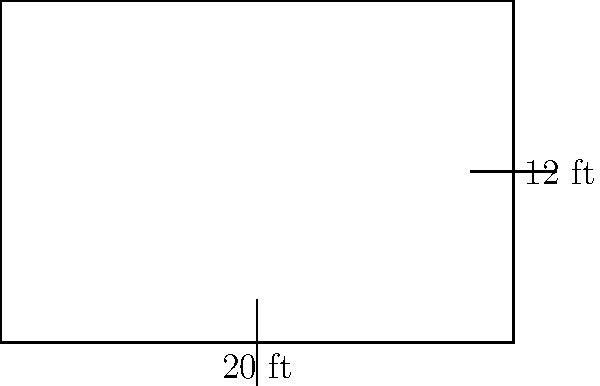A patient records storage room has a rectangular shape with dimensions 20 feet by 12 feet. Calculate the perimeter of the room to determine the length of baseboard needed for renovation. To calculate the perimeter of a rectangular room, we need to sum up the lengths of all sides. Let's break it down step-by-step:

1. Identify the dimensions:
   - Length = 20 feet
   - Width = 12 feet

2. The formula for the perimeter of a rectangle is:
   $P = 2l + 2w$
   Where $P$ is the perimeter, $l$ is the length, and $w$ is the width.

3. Substitute the values into the formula:
   $P = 2(20) + 2(12)$

4. Calculate:
   $P = 40 + 24 = 64$

Therefore, the perimeter of the patient records storage room is 64 feet.
Answer: 64 feet 